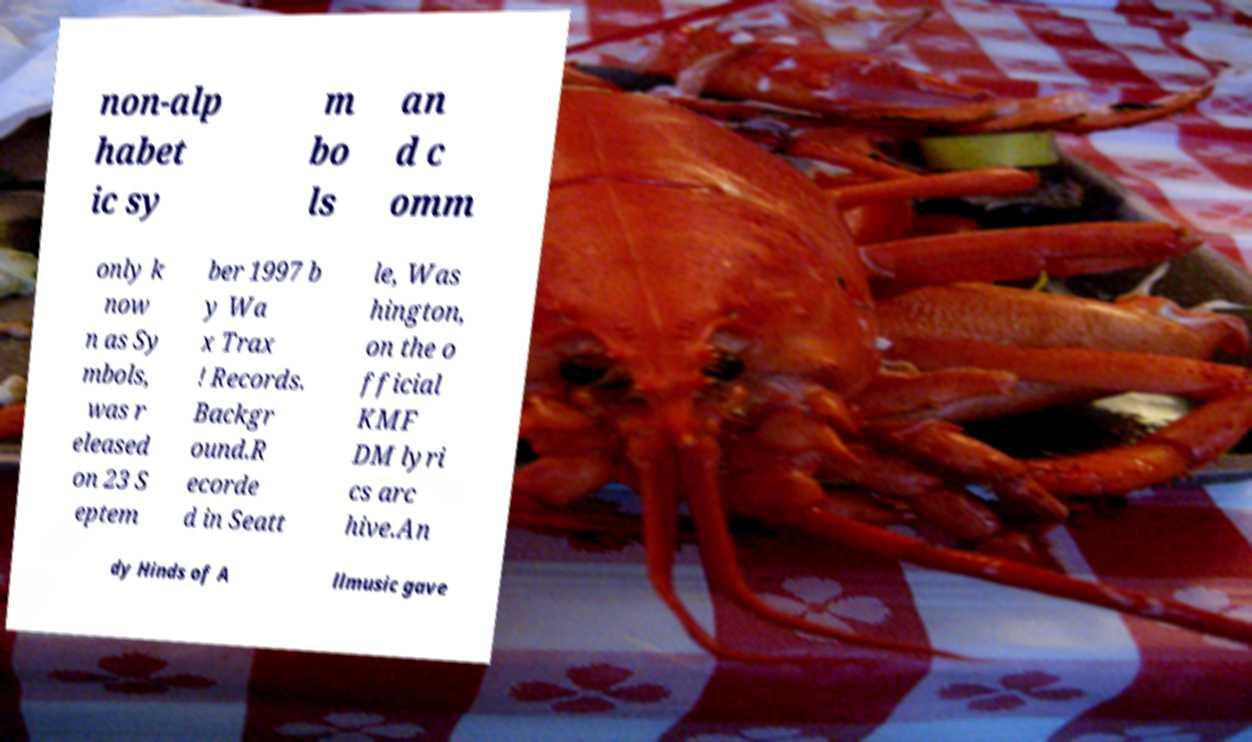Could you assist in decoding the text presented in this image and type it out clearly? non-alp habet ic sy m bo ls an d c omm only k now n as Sy mbols, was r eleased on 23 S eptem ber 1997 b y Wa x Trax ! Records. Backgr ound.R ecorde d in Seatt le, Was hington, on the o fficial KMF DM lyri cs arc hive.An dy Hinds of A llmusic gave 